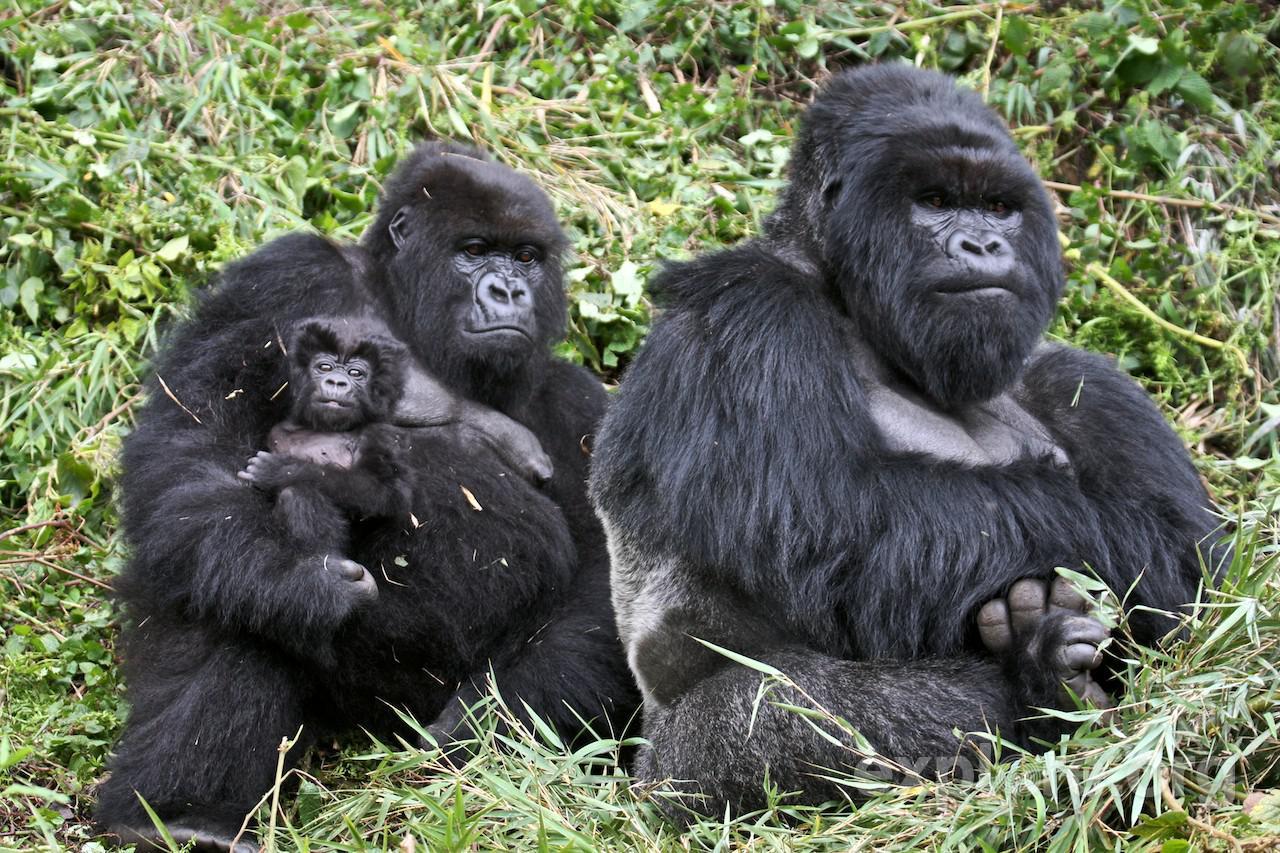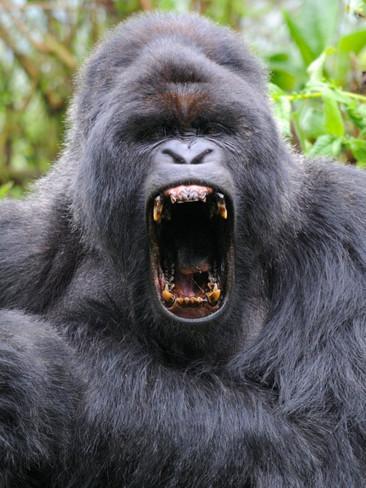The first image is the image on the left, the second image is the image on the right. Given the left and right images, does the statement "One image shows exactly three gorillas, including a baby." hold true? Answer yes or no. Yes. 